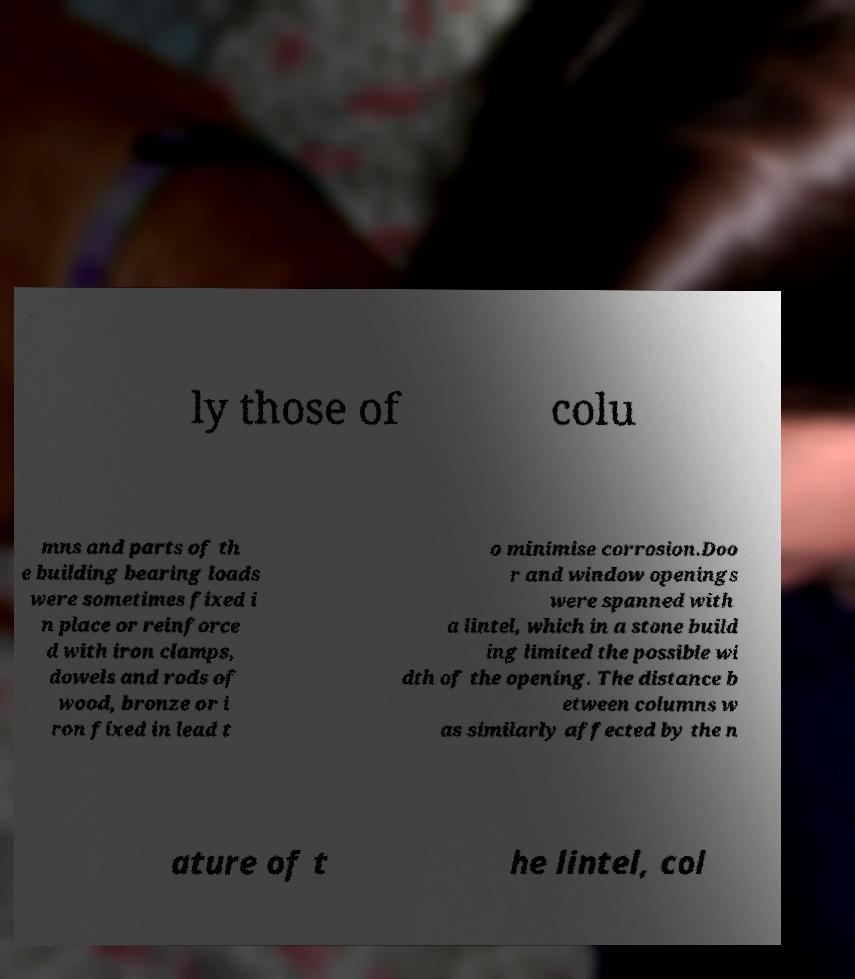Can you read and provide the text displayed in the image?This photo seems to have some interesting text. Can you extract and type it out for me? ly those of colu mns and parts of th e building bearing loads were sometimes fixed i n place or reinforce d with iron clamps, dowels and rods of wood, bronze or i ron fixed in lead t o minimise corrosion.Doo r and window openings were spanned with a lintel, which in a stone build ing limited the possible wi dth of the opening. The distance b etween columns w as similarly affected by the n ature of t he lintel, col 